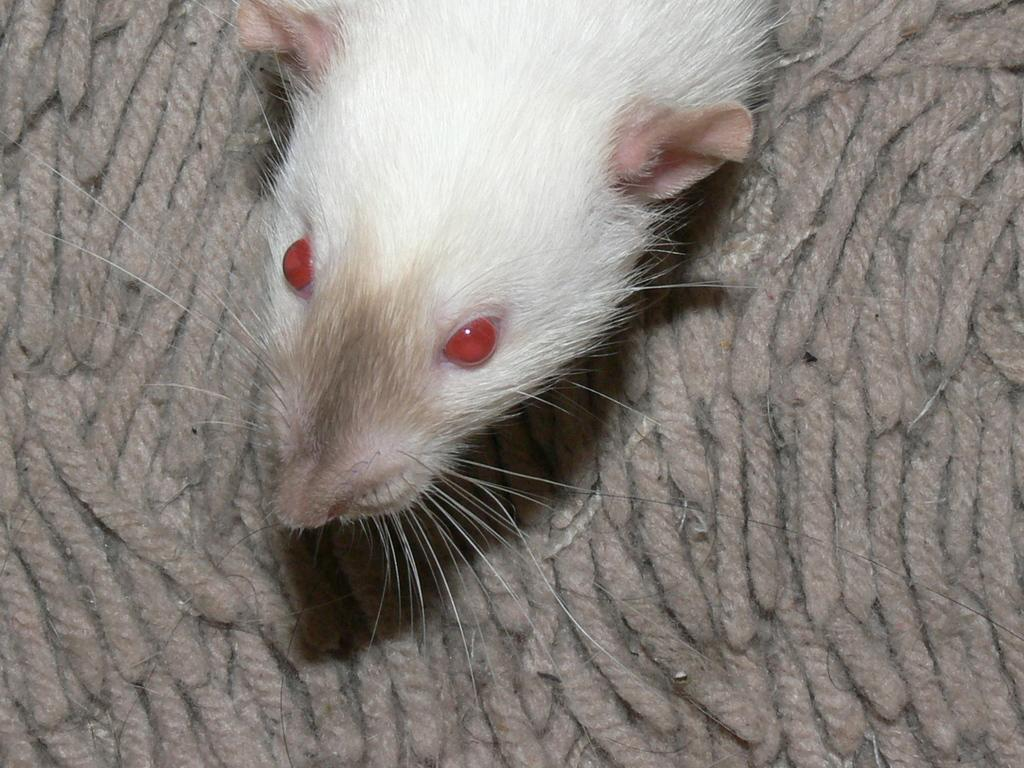What type of animal is in the image? There is a white-colored rat in the image. What color are the rat's eyes? The rat's eyes are red in color. How many chairs are placed around the pot in the image? There is no pot or chairs present in the image; it features a white-colored rat with red eyes. 